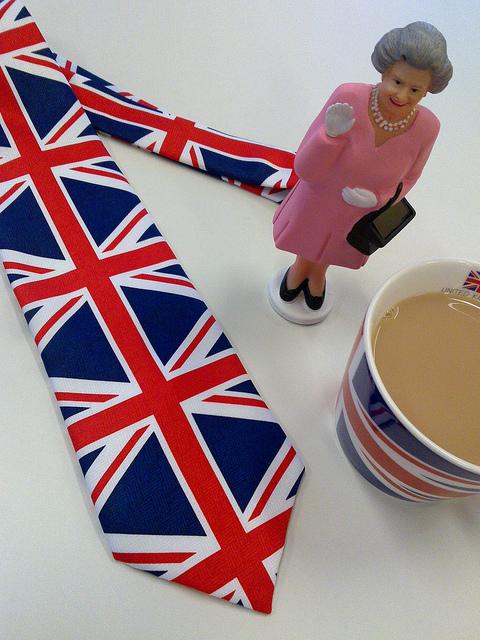How many ties are shown?
Short answer required. 1. What color shoes is she wearing?
Keep it brief. Black. How many colors are present?
Quick response, please. 7. What country does the tie represent?
Concise answer only. England. What is this shoe made of?
Write a very short answer. Leather. What is the name of the person represented by the doll?
Keep it brief. Queen elizabeth. 